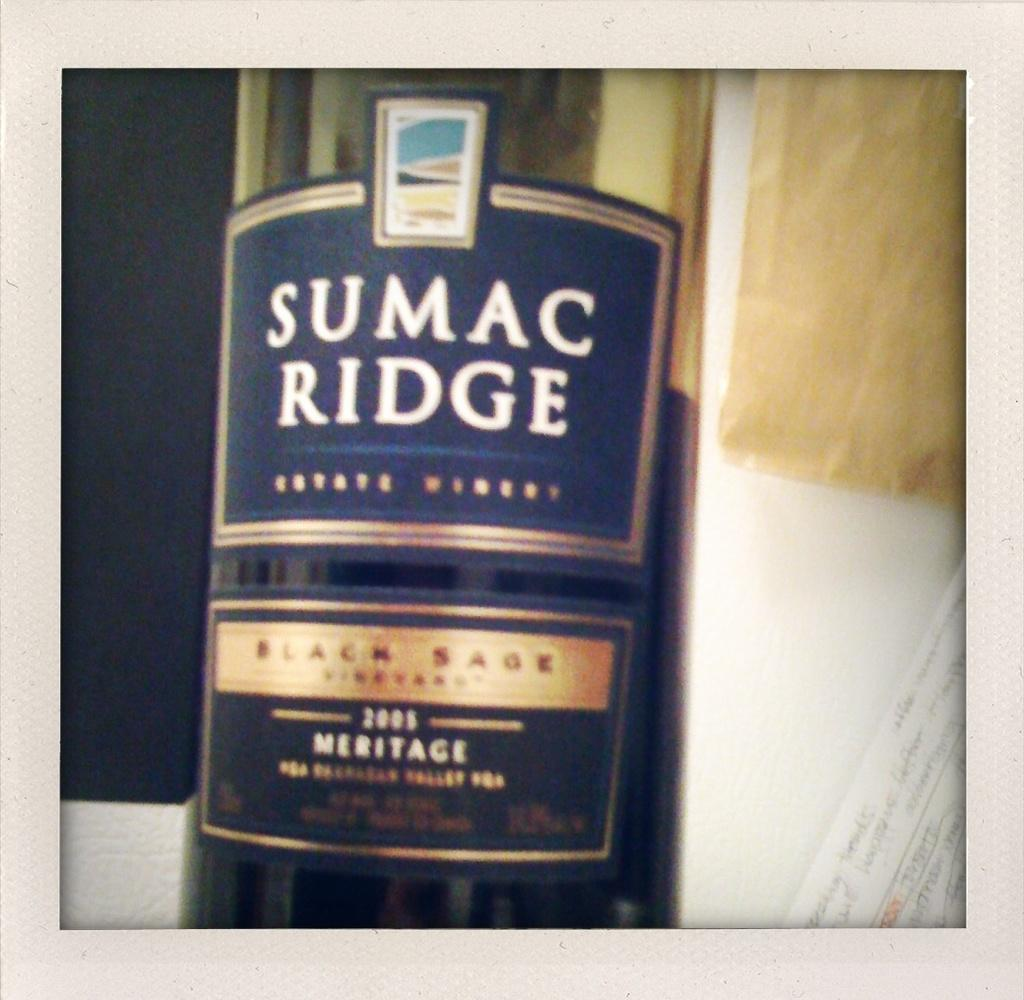<image>
Offer a succinct explanation of the picture presented. A bottle of SUMAC RIDGE sits against a blue and white background 